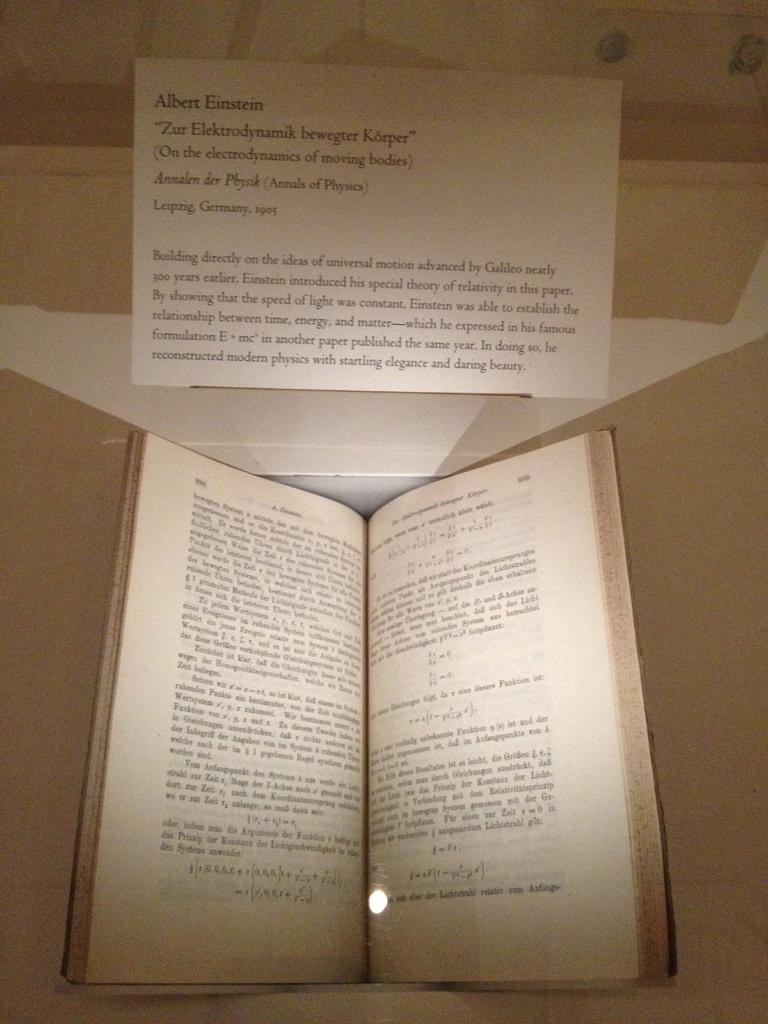What book is this?
Make the answer very short. Zur elektrodynamik bewegter korper. What is the bold string in the first line?
Make the answer very short. Albert einstein. 